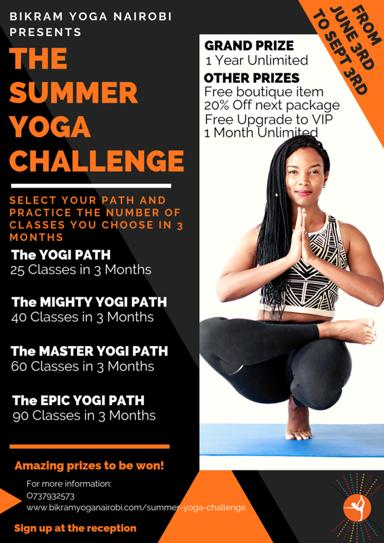What is the event being advertised in the image?
 The event being advertised is the Summer Yoga Challenge at Bikram Yoga Nairobi. What are the different paths one can choose to participate in the challenge? 1. The Yogi Path: 25 classes in 3 months.
2. The Mighty Yogi Path: 40 classes in 3 months.
3. The Master Yogi Path: 60 classes in 3 months.
4. The Epic Yogi Path: 90 classes in 3 months. What are some of the prizes available for participants in the challenge? Some of the prizes include a grand prize of 1-year unlimited yoga, a free boutique item, 20% off the next package, and a free upgrade to VIP 1-month unlimited yoga. How can someone sign up for the Summer Yoga Challenge? To sign up for the Summer Yoga Challenge, one can register at the reception or contact Bikram Yoga Nairobi at 0737932578. More information about the challenge is also available on their website, www.bikramyoganairobi.com. 